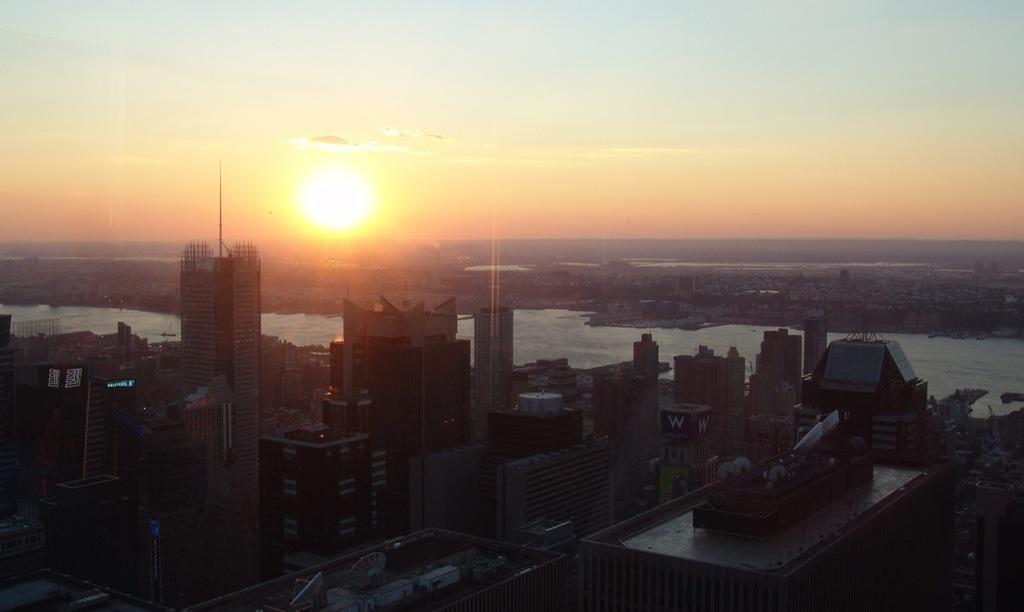Please provide a concise description of this image. In this image we can see some buildings, a lake, the sun and the sky which looks cloudy. 